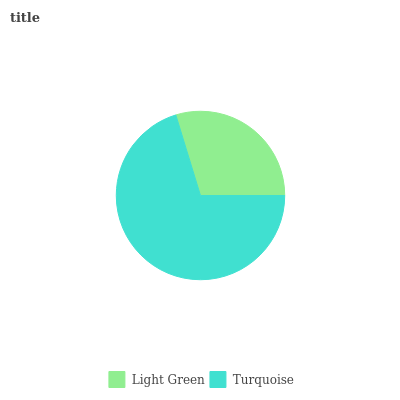Is Light Green the minimum?
Answer yes or no. Yes. Is Turquoise the maximum?
Answer yes or no. Yes. Is Turquoise the minimum?
Answer yes or no. No. Is Turquoise greater than Light Green?
Answer yes or no. Yes. Is Light Green less than Turquoise?
Answer yes or no. Yes. Is Light Green greater than Turquoise?
Answer yes or no. No. Is Turquoise less than Light Green?
Answer yes or no. No. Is Turquoise the high median?
Answer yes or no. Yes. Is Light Green the low median?
Answer yes or no. Yes. Is Light Green the high median?
Answer yes or no. No. Is Turquoise the low median?
Answer yes or no. No. 